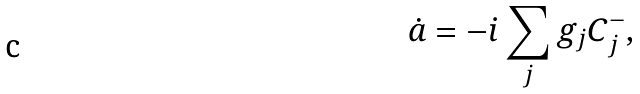<formula> <loc_0><loc_0><loc_500><loc_500>\dot { a } = - i \sum _ { j } g _ { j } C _ { j } ^ { - } ,</formula> 